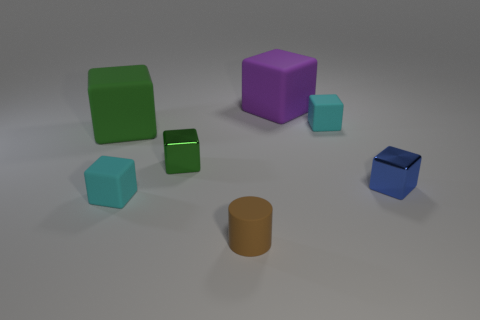Subtract all tiny matte cubes. How many cubes are left? 4 Add 2 purple metallic spheres. How many objects exist? 9 Subtract all purple cubes. How many cubes are left? 5 Subtract all cylinders. How many objects are left? 6 Subtract all red cubes. How many gray cylinders are left? 0 Subtract all small rubber things. Subtract all big green objects. How many objects are left? 3 Add 1 small brown rubber things. How many small brown rubber things are left? 2 Add 1 cyan matte objects. How many cyan matte objects exist? 3 Subtract 1 brown cylinders. How many objects are left? 6 Subtract 4 blocks. How many blocks are left? 2 